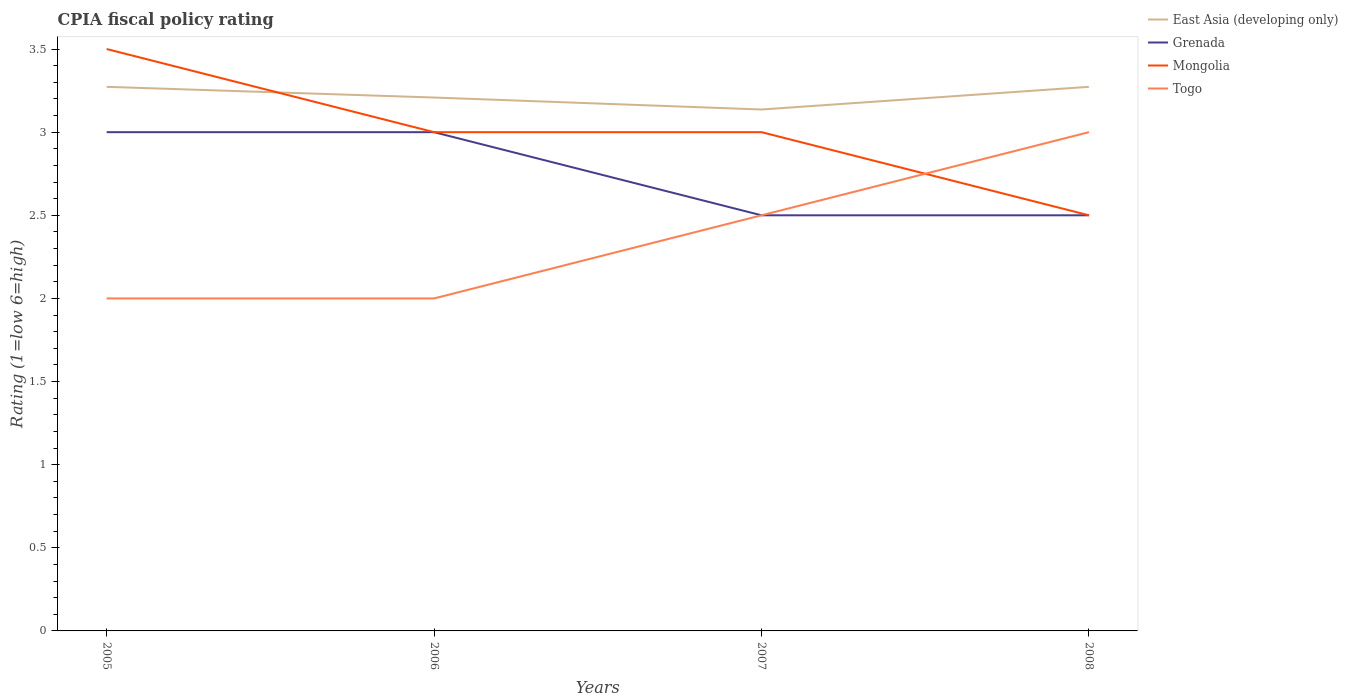Does the line corresponding to Togo intersect with the line corresponding to East Asia (developing only)?
Your response must be concise. No. Across all years, what is the maximum CPIA rating in Mongolia?
Make the answer very short. 2.5. In which year was the CPIA rating in Mongolia maximum?
Your answer should be compact. 2008. What is the difference between the highest and the second highest CPIA rating in Grenada?
Your response must be concise. 0.5. Is the CPIA rating in Mongolia strictly greater than the CPIA rating in East Asia (developing only) over the years?
Provide a short and direct response. No. How many lines are there?
Give a very brief answer. 4. Does the graph contain any zero values?
Your answer should be very brief. No. How many legend labels are there?
Provide a short and direct response. 4. How are the legend labels stacked?
Provide a succinct answer. Vertical. What is the title of the graph?
Your response must be concise. CPIA fiscal policy rating. Does "Malaysia" appear as one of the legend labels in the graph?
Give a very brief answer. No. What is the label or title of the Y-axis?
Offer a very short reply. Rating (1=low 6=high). What is the Rating (1=low 6=high) of East Asia (developing only) in 2005?
Offer a very short reply. 3.27. What is the Rating (1=low 6=high) in Togo in 2005?
Provide a succinct answer. 2. What is the Rating (1=low 6=high) of East Asia (developing only) in 2006?
Offer a very short reply. 3.21. What is the Rating (1=low 6=high) of Grenada in 2006?
Give a very brief answer. 3. What is the Rating (1=low 6=high) in Togo in 2006?
Your answer should be very brief. 2. What is the Rating (1=low 6=high) in East Asia (developing only) in 2007?
Offer a very short reply. 3.14. What is the Rating (1=low 6=high) in Mongolia in 2007?
Your answer should be compact. 3. What is the Rating (1=low 6=high) in Togo in 2007?
Provide a short and direct response. 2.5. What is the Rating (1=low 6=high) in East Asia (developing only) in 2008?
Provide a succinct answer. 3.27. What is the Rating (1=low 6=high) in Grenada in 2008?
Ensure brevity in your answer.  2.5. What is the Rating (1=low 6=high) in Mongolia in 2008?
Your response must be concise. 2.5. What is the Rating (1=low 6=high) of Togo in 2008?
Offer a very short reply. 3. Across all years, what is the maximum Rating (1=low 6=high) in East Asia (developing only)?
Your answer should be compact. 3.27. Across all years, what is the maximum Rating (1=low 6=high) of Grenada?
Your answer should be very brief. 3. Across all years, what is the maximum Rating (1=low 6=high) in Mongolia?
Your response must be concise. 3.5. Across all years, what is the maximum Rating (1=low 6=high) in Togo?
Give a very brief answer. 3. Across all years, what is the minimum Rating (1=low 6=high) of East Asia (developing only)?
Offer a terse response. 3.14. Across all years, what is the minimum Rating (1=low 6=high) in Mongolia?
Give a very brief answer. 2.5. Across all years, what is the minimum Rating (1=low 6=high) in Togo?
Offer a terse response. 2. What is the total Rating (1=low 6=high) in East Asia (developing only) in the graph?
Provide a succinct answer. 12.89. What is the total Rating (1=low 6=high) of Mongolia in the graph?
Make the answer very short. 12. What is the total Rating (1=low 6=high) in Togo in the graph?
Your answer should be very brief. 9.5. What is the difference between the Rating (1=low 6=high) in East Asia (developing only) in 2005 and that in 2006?
Keep it short and to the point. 0.06. What is the difference between the Rating (1=low 6=high) in Grenada in 2005 and that in 2006?
Ensure brevity in your answer.  0. What is the difference between the Rating (1=low 6=high) in Mongolia in 2005 and that in 2006?
Your answer should be compact. 0.5. What is the difference between the Rating (1=low 6=high) in Togo in 2005 and that in 2006?
Keep it short and to the point. 0. What is the difference between the Rating (1=low 6=high) in East Asia (developing only) in 2005 and that in 2007?
Your answer should be very brief. 0.14. What is the difference between the Rating (1=low 6=high) of Grenada in 2005 and that in 2007?
Your answer should be very brief. 0.5. What is the difference between the Rating (1=low 6=high) in Togo in 2005 and that in 2007?
Ensure brevity in your answer.  -0.5. What is the difference between the Rating (1=low 6=high) in East Asia (developing only) in 2005 and that in 2008?
Keep it short and to the point. 0. What is the difference between the Rating (1=low 6=high) in East Asia (developing only) in 2006 and that in 2007?
Provide a succinct answer. 0.07. What is the difference between the Rating (1=low 6=high) of Grenada in 2006 and that in 2007?
Offer a very short reply. 0.5. What is the difference between the Rating (1=low 6=high) in East Asia (developing only) in 2006 and that in 2008?
Give a very brief answer. -0.06. What is the difference between the Rating (1=low 6=high) of Grenada in 2006 and that in 2008?
Keep it short and to the point. 0.5. What is the difference between the Rating (1=low 6=high) of Mongolia in 2006 and that in 2008?
Offer a very short reply. 0.5. What is the difference between the Rating (1=low 6=high) in East Asia (developing only) in 2007 and that in 2008?
Your response must be concise. -0.14. What is the difference between the Rating (1=low 6=high) in Grenada in 2007 and that in 2008?
Ensure brevity in your answer.  0. What is the difference between the Rating (1=low 6=high) of Mongolia in 2007 and that in 2008?
Make the answer very short. 0.5. What is the difference between the Rating (1=low 6=high) of East Asia (developing only) in 2005 and the Rating (1=low 6=high) of Grenada in 2006?
Keep it short and to the point. 0.27. What is the difference between the Rating (1=low 6=high) of East Asia (developing only) in 2005 and the Rating (1=low 6=high) of Mongolia in 2006?
Your response must be concise. 0.27. What is the difference between the Rating (1=low 6=high) in East Asia (developing only) in 2005 and the Rating (1=low 6=high) in Togo in 2006?
Provide a succinct answer. 1.27. What is the difference between the Rating (1=low 6=high) of Grenada in 2005 and the Rating (1=low 6=high) of Togo in 2006?
Your answer should be very brief. 1. What is the difference between the Rating (1=low 6=high) in Mongolia in 2005 and the Rating (1=low 6=high) in Togo in 2006?
Keep it short and to the point. 1.5. What is the difference between the Rating (1=low 6=high) in East Asia (developing only) in 2005 and the Rating (1=low 6=high) in Grenada in 2007?
Make the answer very short. 0.77. What is the difference between the Rating (1=low 6=high) of East Asia (developing only) in 2005 and the Rating (1=low 6=high) of Mongolia in 2007?
Provide a succinct answer. 0.27. What is the difference between the Rating (1=low 6=high) of East Asia (developing only) in 2005 and the Rating (1=low 6=high) of Togo in 2007?
Provide a short and direct response. 0.77. What is the difference between the Rating (1=low 6=high) in Grenada in 2005 and the Rating (1=low 6=high) in Togo in 2007?
Your response must be concise. 0.5. What is the difference between the Rating (1=low 6=high) of Mongolia in 2005 and the Rating (1=low 6=high) of Togo in 2007?
Keep it short and to the point. 1. What is the difference between the Rating (1=low 6=high) in East Asia (developing only) in 2005 and the Rating (1=low 6=high) in Grenada in 2008?
Keep it short and to the point. 0.77. What is the difference between the Rating (1=low 6=high) in East Asia (developing only) in 2005 and the Rating (1=low 6=high) in Mongolia in 2008?
Make the answer very short. 0.77. What is the difference between the Rating (1=low 6=high) in East Asia (developing only) in 2005 and the Rating (1=low 6=high) in Togo in 2008?
Keep it short and to the point. 0.27. What is the difference between the Rating (1=low 6=high) of Grenada in 2005 and the Rating (1=low 6=high) of Togo in 2008?
Make the answer very short. 0. What is the difference between the Rating (1=low 6=high) of Mongolia in 2005 and the Rating (1=low 6=high) of Togo in 2008?
Your response must be concise. 0.5. What is the difference between the Rating (1=low 6=high) in East Asia (developing only) in 2006 and the Rating (1=low 6=high) in Grenada in 2007?
Keep it short and to the point. 0.71. What is the difference between the Rating (1=low 6=high) of East Asia (developing only) in 2006 and the Rating (1=low 6=high) of Mongolia in 2007?
Your answer should be very brief. 0.21. What is the difference between the Rating (1=low 6=high) in East Asia (developing only) in 2006 and the Rating (1=low 6=high) in Togo in 2007?
Offer a terse response. 0.71. What is the difference between the Rating (1=low 6=high) of East Asia (developing only) in 2006 and the Rating (1=low 6=high) of Grenada in 2008?
Offer a terse response. 0.71. What is the difference between the Rating (1=low 6=high) of East Asia (developing only) in 2006 and the Rating (1=low 6=high) of Mongolia in 2008?
Provide a short and direct response. 0.71. What is the difference between the Rating (1=low 6=high) in East Asia (developing only) in 2006 and the Rating (1=low 6=high) in Togo in 2008?
Provide a short and direct response. 0.21. What is the difference between the Rating (1=low 6=high) in Grenada in 2006 and the Rating (1=low 6=high) in Togo in 2008?
Provide a succinct answer. 0. What is the difference between the Rating (1=low 6=high) of Mongolia in 2006 and the Rating (1=low 6=high) of Togo in 2008?
Offer a terse response. 0. What is the difference between the Rating (1=low 6=high) of East Asia (developing only) in 2007 and the Rating (1=low 6=high) of Grenada in 2008?
Your answer should be compact. 0.64. What is the difference between the Rating (1=low 6=high) of East Asia (developing only) in 2007 and the Rating (1=low 6=high) of Mongolia in 2008?
Your response must be concise. 0.64. What is the difference between the Rating (1=low 6=high) of East Asia (developing only) in 2007 and the Rating (1=low 6=high) of Togo in 2008?
Your response must be concise. 0.14. What is the difference between the Rating (1=low 6=high) of Grenada in 2007 and the Rating (1=low 6=high) of Mongolia in 2008?
Your answer should be very brief. 0. What is the difference between the Rating (1=low 6=high) in Mongolia in 2007 and the Rating (1=low 6=high) in Togo in 2008?
Offer a terse response. 0. What is the average Rating (1=low 6=high) of East Asia (developing only) per year?
Your answer should be very brief. 3.22. What is the average Rating (1=low 6=high) in Grenada per year?
Give a very brief answer. 2.75. What is the average Rating (1=low 6=high) of Mongolia per year?
Provide a succinct answer. 3. What is the average Rating (1=low 6=high) in Togo per year?
Offer a terse response. 2.38. In the year 2005, what is the difference between the Rating (1=low 6=high) in East Asia (developing only) and Rating (1=low 6=high) in Grenada?
Provide a short and direct response. 0.27. In the year 2005, what is the difference between the Rating (1=low 6=high) of East Asia (developing only) and Rating (1=low 6=high) of Mongolia?
Your answer should be very brief. -0.23. In the year 2005, what is the difference between the Rating (1=low 6=high) in East Asia (developing only) and Rating (1=low 6=high) in Togo?
Provide a succinct answer. 1.27. In the year 2005, what is the difference between the Rating (1=low 6=high) of Grenada and Rating (1=low 6=high) of Mongolia?
Provide a short and direct response. -0.5. In the year 2006, what is the difference between the Rating (1=low 6=high) of East Asia (developing only) and Rating (1=low 6=high) of Grenada?
Make the answer very short. 0.21. In the year 2006, what is the difference between the Rating (1=low 6=high) in East Asia (developing only) and Rating (1=low 6=high) in Mongolia?
Ensure brevity in your answer.  0.21. In the year 2006, what is the difference between the Rating (1=low 6=high) of East Asia (developing only) and Rating (1=low 6=high) of Togo?
Your answer should be very brief. 1.21. In the year 2006, what is the difference between the Rating (1=low 6=high) of Grenada and Rating (1=low 6=high) of Mongolia?
Your answer should be very brief. 0. In the year 2007, what is the difference between the Rating (1=low 6=high) in East Asia (developing only) and Rating (1=low 6=high) in Grenada?
Your answer should be very brief. 0.64. In the year 2007, what is the difference between the Rating (1=low 6=high) in East Asia (developing only) and Rating (1=low 6=high) in Mongolia?
Make the answer very short. 0.14. In the year 2007, what is the difference between the Rating (1=low 6=high) of East Asia (developing only) and Rating (1=low 6=high) of Togo?
Provide a short and direct response. 0.64. In the year 2007, what is the difference between the Rating (1=low 6=high) in Grenada and Rating (1=low 6=high) in Togo?
Provide a short and direct response. 0. In the year 2008, what is the difference between the Rating (1=low 6=high) in East Asia (developing only) and Rating (1=low 6=high) in Grenada?
Provide a short and direct response. 0.77. In the year 2008, what is the difference between the Rating (1=low 6=high) in East Asia (developing only) and Rating (1=low 6=high) in Mongolia?
Offer a terse response. 0.77. In the year 2008, what is the difference between the Rating (1=low 6=high) of East Asia (developing only) and Rating (1=low 6=high) of Togo?
Your answer should be compact. 0.27. In the year 2008, what is the difference between the Rating (1=low 6=high) of Mongolia and Rating (1=low 6=high) of Togo?
Make the answer very short. -0.5. What is the ratio of the Rating (1=low 6=high) of East Asia (developing only) in 2005 to that in 2006?
Keep it short and to the point. 1.02. What is the ratio of the Rating (1=low 6=high) of Grenada in 2005 to that in 2006?
Provide a short and direct response. 1. What is the ratio of the Rating (1=low 6=high) in Mongolia in 2005 to that in 2006?
Give a very brief answer. 1.17. What is the ratio of the Rating (1=low 6=high) in Togo in 2005 to that in 2006?
Your response must be concise. 1. What is the ratio of the Rating (1=low 6=high) of East Asia (developing only) in 2005 to that in 2007?
Your answer should be very brief. 1.04. What is the ratio of the Rating (1=low 6=high) of Grenada in 2005 to that in 2007?
Give a very brief answer. 1.2. What is the ratio of the Rating (1=low 6=high) in Mongolia in 2005 to that in 2007?
Give a very brief answer. 1.17. What is the ratio of the Rating (1=low 6=high) of Togo in 2005 to that in 2007?
Your answer should be compact. 0.8. What is the ratio of the Rating (1=low 6=high) in East Asia (developing only) in 2005 to that in 2008?
Your answer should be very brief. 1. What is the ratio of the Rating (1=low 6=high) of Grenada in 2005 to that in 2008?
Your response must be concise. 1.2. What is the ratio of the Rating (1=low 6=high) of Mongolia in 2005 to that in 2008?
Your answer should be very brief. 1.4. What is the ratio of the Rating (1=low 6=high) of Togo in 2005 to that in 2008?
Offer a terse response. 0.67. What is the ratio of the Rating (1=low 6=high) in East Asia (developing only) in 2006 to that in 2007?
Give a very brief answer. 1.02. What is the ratio of the Rating (1=low 6=high) of Mongolia in 2006 to that in 2007?
Make the answer very short. 1. What is the ratio of the Rating (1=low 6=high) in East Asia (developing only) in 2006 to that in 2008?
Provide a short and direct response. 0.98. What is the ratio of the Rating (1=low 6=high) of Grenada in 2006 to that in 2008?
Give a very brief answer. 1.2. What is the ratio of the Rating (1=low 6=high) in Mongolia in 2006 to that in 2008?
Keep it short and to the point. 1.2. What is the ratio of the Rating (1=low 6=high) of East Asia (developing only) in 2007 to that in 2008?
Give a very brief answer. 0.96. What is the ratio of the Rating (1=low 6=high) of Mongolia in 2007 to that in 2008?
Your answer should be very brief. 1.2. What is the ratio of the Rating (1=low 6=high) of Togo in 2007 to that in 2008?
Ensure brevity in your answer.  0.83. What is the difference between the highest and the second highest Rating (1=low 6=high) in East Asia (developing only)?
Provide a succinct answer. 0. What is the difference between the highest and the second highest Rating (1=low 6=high) of Mongolia?
Ensure brevity in your answer.  0.5. What is the difference between the highest and the second highest Rating (1=low 6=high) in Togo?
Offer a terse response. 0.5. What is the difference between the highest and the lowest Rating (1=low 6=high) of East Asia (developing only)?
Ensure brevity in your answer.  0.14. What is the difference between the highest and the lowest Rating (1=low 6=high) in Grenada?
Offer a very short reply. 0.5. What is the difference between the highest and the lowest Rating (1=low 6=high) of Togo?
Your answer should be very brief. 1. 